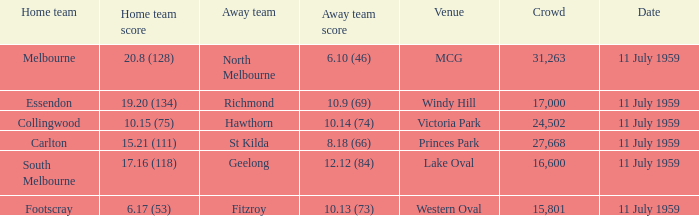Parse the table in full. {'header': ['Home team', 'Home team score', 'Away team', 'Away team score', 'Venue', 'Crowd', 'Date'], 'rows': [['Melbourne', '20.8 (128)', 'North Melbourne', '6.10 (46)', 'MCG', '31,263', '11 July 1959'], ['Essendon', '19.20 (134)', 'Richmond', '10.9 (69)', 'Windy Hill', '17,000', '11 July 1959'], ['Collingwood', '10.15 (75)', 'Hawthorn', '10.14 (74)', 'Victoria Park', '24,502', '11 July 1959'], ['Carlton', '15.21 (111)', 'St Kilda', '8.18 (66)', 'Princes Park', '27,668', '11 July 1959'], ['South Melbourne', '17.16 (118)', 'Geelong', '12.12 (84)', 'Lake Oval', '16,600', '11 July 1959'], ['Footscray', '6.17 (53)', 'Fitzroy', '10.13 (73)', 'Western Oval', '15,801', '11 July 1959']]} What is the home team's points when richmond is on the road? 19.20 (134). 